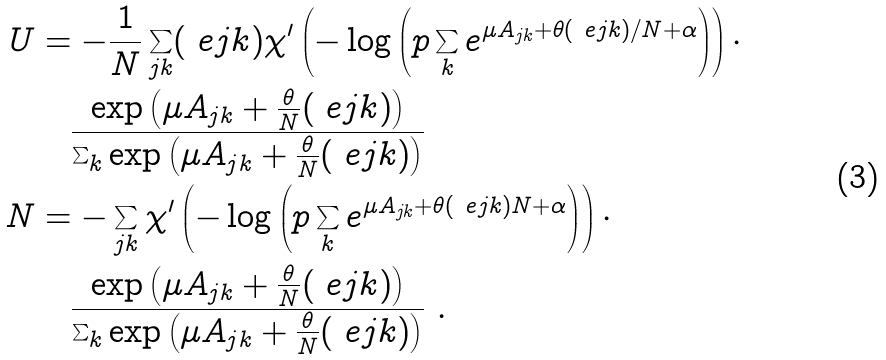Convert formula to latex. <formula><loc_0><loc_0><loc_500><loc_500>U & = - \frac { 1 } { N } \sum _ { j k } ( \ e j k ) \chi ^ { \prime } \left ( - \log \left ( p \sum _ { k } e ^ { \mu A _ { j k } + \theta ( \ e j k ) / N + \alpha } \right ) \right ) \cdot \\ & \quad \frac { \exp \left ( \mu A _ { j k } + \frac { \theta } N ( \ e j k ) \right ) } { \sum _ { k } \exp \left ( \mu A _ { j k } + \frac { \theta } N ( \ e j k ) \right ) } \\ N & = - \sum _ { j k } \chi ^ { \prime } \left ( - \log \left ( p \sum _ { k } e ^ { \mu A _ { j k } + \theta ( \ e j k ) N + \alpha } \right ) \right ) \cdot \\ & \quad \frac { \exp \left ( \mu A _ { j k } + \frac { \theta } N ( \ e j k ) \right ) } { \sum _ { k } \exp \left ( \mu A _ { j k } + \frac { \theta } N ( \ e j k ) \right ) } \ .</formula> 